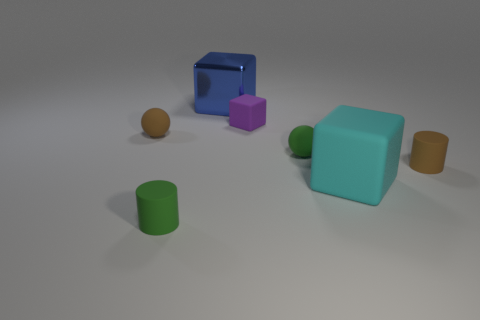Is the size of the metal thing the same as the block in front of the tiny purple thing?
Provide a succinct answer. Yes. Does the small purple block have the same material as the large cyan cube?
Provide a short and direct response. Yes. How many tiny matte balls are behind the large cyan thing?
Your answer should be very brief. 2. There is a small thing that is both on the right side of the small brown sphere and on the left side of the tiny purple matte thing; what is its material?
Offer a terse response. Rubber. What number of matte objects have the same size as the blue shiny cube?
Keep it short and to the point. 1. There is a tiny rubber cylinder that is behind the green thing left of the tiny purple rubber block; what color is it?
Keep it short and to the point. Brown. Is there a small yellow metal cube?
Keep it short and to the point. No. Does the metal thing have the same shape as the large cyan rubber thing?
Ensure brevity in your answer.  Yes. There is a matte cylinder to the right of the small green matte sphere; what number of purple matte cubes are in front of it?
Offer a very short reply. 0. How many objects are in front of the tiny purple cube and to the left of the cyan matte cube?
Your answer should be very brief. 3. 